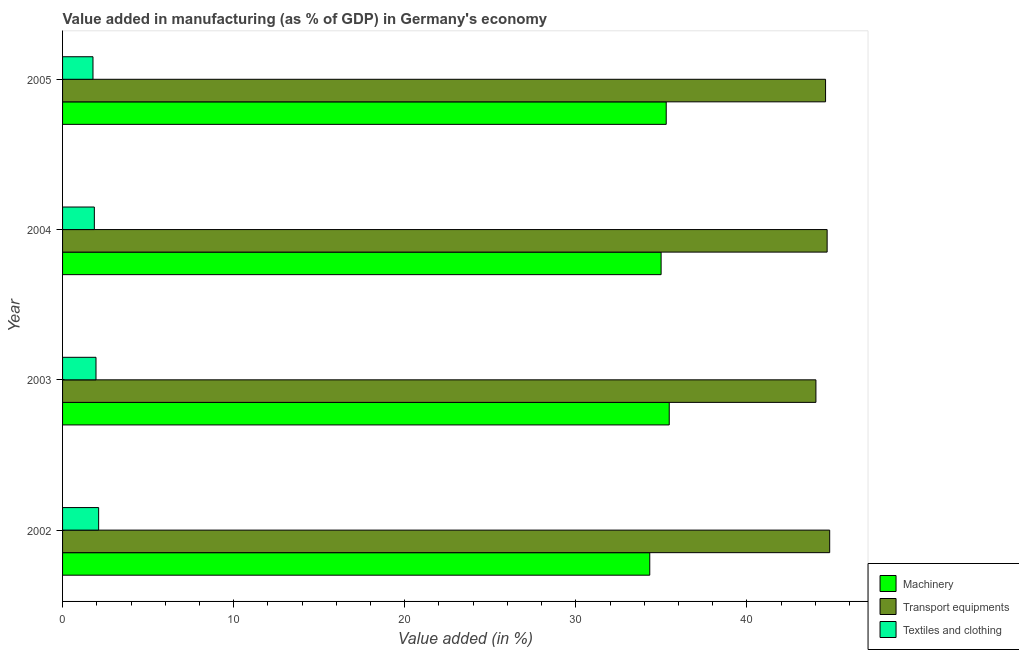How many different coloured bars are there?
Keep it short and to the point. 3. Are the number of bars per tick equal to the number of legend labels?
Your answer should be very brief. Yes. Are the number of bars on each tick of the Y-axis equal?
Offer a terse response. Yes. How many bars are there on the 3rd tick from the top?
Keep it short and to the point. 3. How many bars are there on the 3rd tick from the bottom?
Make the answer very short. 3. In how many cases, is the number of bars for a given year not equal to the number of legend labels?
Give a very brief answer. 0. What is the value added in manufacturing transport equipments in 2002?
Ensure brevity in your answer.  44.84. Across all years, what is the maximum value added in manufacturing textile and clothing?
Keep it short and to the point. 2.11. Across all years, what is the minimum value added in manufacturing textile and clothing?
Your answer should be very brief. 1.78. In which year was the value added in manufacturing textile and clothing maximum?
Provide a succinct answer. 2002. In which year was the value added in manufacturing textile and clothing minimum?
Your response must be concise. 2005. What is the total value added in manufacturing machinery in the graph?
Make the answer very short. 140.04. What is the difference between the value added in manufacturing machinery in 2002 and that in 2004?
Your response must be concise. -0.66. What is the difference between the value added in manufacturing machinery in 2003 and the value added in manufacturing transport equipments in 2004?
Provide a succinct answer. -9.23. What is the average value added in manufacturing transport equipments per year?
Make the answer very short. 44.54. In the year 2003, what is the difference between the value added in manufacturing machinery and value added in manufacturing textile and clothing?
Your response must be concise. 33.5. What is the ratio of the value added in manufacturing textile and clothing in 2002 to that in 2005?
Ensure brevity in your answer.  1.19. Is the value added in manufacturing machinery in 2003 less than that in 2004?
Provide a short and direct response. No. Is the difference between the value added in manufacturing textile and clothing in 2004 and 2005 greater than the difference between the value added in manufacturing machinery in 2004 and 2005?
Your answer should be compact. Yes. What is the difference between the highest and the second highest value added in manufacturing transport equipments?
Your response must be concise. 0.15. What is the difference between the highest and the lowest value added in manufacturing textile and clothing?
Ensure brevity in your answer.  0.33. What does the 1st bar from the top in 2004 represents?
Keep it short and to the point. Textiles and clothing. What does the 1st bar from the bottom in 2003 represents?
Provide a short and direct response. Machinery. How many bars are there?
Ensure brevity in your answer.  12. How many years are there in the graph?
Your answer should be compact. 4. What is the difference between two consecutive major ticks on the X-axis?
Offer a terse response. 10. Are the values on the major ticks of X-axis written in scientific E-notation?
Provide a short and direct response. No. Does the graph contain any zero values?
Your answer should be compact. No. Does the graph contain grids?
Your response must be concise. No. How are the legend labels stacked?
Make the answer very short. Vertical. What is the title of the graph?
Make the answer very short. Value added in manufacturing (as % of GDP) in Germany's economy. What is the label or title of the X-axis?
Provide a short and direct response. Value added (in %). What is the Value added (in %) in Machinery in 2002?
Provide a short and direct response. 34.32. What is the Value added (in %) of Transport equipments in 2002?
Your response must be concise. 44.84. What is the Value added (in %) in Textiles and clothing in 2002?
Your response must be concise. 2.11. What is the Value added (in %) of Machinery in 2003?
Offer a terse response. 35.46. What is the Value added (in %) of Transport equipments in 2003?
Keep it short and to the point. 44.03. What is the Value added (in %) of Textiles and clothing in 2003?
Offer a very short reply. 1.95. What is the Value added (in %) in Machinery in 2004?
Ensure brevity in your answer.  34.98. What is the Value added (in %) of Transport equipments in 2004?
Your answer should be compact. 44.69. What is the Value added (in %) of Textiles and clothing in 2004?
Offer a very short reply. 1.86. What is the Value added (in %) in Machinery in 2005?
Offer a very short reply. 35.28. What is the Value added (in %) in Transport equipments in 2005?
Provide a succinct answer. 44.6. What is the Value added (in %) of Textiles and clothing in 2005?
Provide a short and direct response. 1.78. Across all years, what is the maximum Value added (in %) of Machinery?
Ensure brevity in your answer.  35.46. Across all years, what is the maximum Value added (in %) of Transport equipments?
Your answer should be very brief. 44.84. Across all years, what is the maximum Value added (in %) in Textiles and clothing?
Give a very brief answer. 2.11. Across all years, what is the minimum Value added (in %) in Machinery?
Keep it short and to the point. 34.32. Across all years, what is the minimum Value added (in %) in Transport equipments?
Offer a terse response. 44.03. Across all years, what is the minimum Value added (in %) in Textiles and clothing?
Offer a terse response. 1.78. What is the total Value added (in %) of Machinery in the graph?
Give a very brief answer. 140.04. What is the total Value added (in %) in Transport equipments in the graph?
Offer a very short reply. 178.15. What is the total Value added (in %) in Textiles and clothing in the graph?
Keep it short and to the point. 7.7. What is the difference between the Value added (in %) of Machinery in 2002 and that in 2003?
Your answer should be very brief. -1.14. What is the difference between the Value added (in %) of Transport equipments in 2002 and that in 2003?
Provide a succinct answer. 0.8. What is the difference between the Value added (in %) in Textiles and clothing in 2002 and that in 2003?
Your answer should be very brief. 0.15. What is the difference between the Value added (in %) in Machinery in 2002 and that in 2004?
Your answer should be compact. -0.66. What is the difference between the Value added (in %) of Transport equipments in 2002 and that in 2004?
Offer a very short reply. 0.15. What is the difference between the Value added (in %) of Textiles and clothing in 2002 and that in 2004?
Your answer should be compact. 0.25. What is the difference between the Value added (in %) in Machinery in 2002 and that in 2005?
Offer a terse response. -0.96. What is the difference between the Value added (in %) in Transport equipments in 2002 and that in 2005?
Your answer should be compact. 0.24. What is the difference between the Value added (in %) of Textiles and clothing in 2002 and that in 2005?
Your answer should be very brief. 0.33. What is the difference between the Value added (in %) in Machinery in 2003 and that in 2004?
Ensure brevity in your answer.  0.48. What is the difference between the Value added (in %) of Transport equipments in 2003 and that in 2004?
Your answer should be very brief. -0.65. What is the difference between the Value added (in %) of Textiles and clothing in 2003 and that in 2004?
Give a very brief answer. 0.1. What is the difference between the Value added (in %) in Machinery in 2003 and that in 2005?
Give a very brief answer. 0.18. What is the difference between the Value added (in %) in Transport equipments in 2003 and that in 2005?
Provide a short and direct response. -0.56. What is the difference between the Value added (in %) of Textiles and clothing in 2003 and that in 2005?
Ensure brevity in your answer.  0.18. What is the difference between the Value added (in %) of Machinery in 2004 and that in 2005?
Keep it short and to the point. -0.3. What is the difference between the Value added (in %) in Transport equipments in 2004 and that in 2005?
Keep it short and to the point. 0.09. What is the difference between the Value added (in %) in Textiles and clothing in 2004 and that in 2005?
Provide a succinct answer. 0.08. What is the difference between the Value added (in %) in Machinery in 2002 and the Value added (in %) in Transport equipments in 2003?
Your answer should be very brief. -9.71. What is the difference between the Value added (in %) of Machinery in 2002 and the Value added (in %) of Textiles and clothing in 2003?
Your response must be concise. 32.37. What is the difference between the Value added (in %) in Transport equipments in 2002 and the Value added (in %) in Textiles and clothing in 2003?
Provide a short and direct response. 42.88. What is the difference between the Value added (in %) of Machinery in 2002 and the Value added (in %) of Transport equipments in 2004?
Provide a succinct answer. -10.37. What is the difference between the Value added (in %) in Machinery in 2002 and the Value added (in %) in Textiles and clothing in 2004?
Your answer should be very brief. 32.46. What is the difference between the Value added (in %) in Transport equipments in 2002 and the Value added (in %) in Textiles and clothing in 2004?
Make the answer very short. 42.98. What is the difference between the Value added (in %) of Machinery in 2002 and the Value added (in %) of Transport equipments in 2005?
Ensure brevity in your answer.  -10.27. What is the difference between the Value added (in %) in Machinery in 2002 and the Value added (in %) in Textiles and clothing in 2005?
Provide a short and direct response. 32.54. What is the difference between the Value added (in %) in Transport equipments in 2002 and the Value added (in %) in Textiles and clothing in 2005?
Give a very brief answer. 43.06. What is the difference between the Value added (in %) in Machinery in 2003 and the Value added (in %) in Transport equipments in 2004?
Offer a terse response. -9.23. What is the difference between the Value added (in %) in Machinery in 2003 and the Value added (in %) in Textiles and clothing in 2004?
Keep it short and to the point. 33.6. What is the difference between the Value added (in %) in Transport equipments in 2003 and the Value added (in %) in Textiles and clothing in 2004?
Give a very brief answer. 42.17. What is the difference between the Value added (in %) in Machinery in 2003 and the Value added (in %) in Transport equipments in 2005?
Make the answer very short. -9.14. What is the difference between the Value added (in %) of Machinery in 2003 and the Value added (in %) of Textiles and clothing in 2005?
Your response must be concise. 33.68. What is the difference between the Value added (in %) of Transport equipments in 2003 and the Value added (in %) of Textiles and clothing in 2005?
Provide a short and direct response. 42.25. What is the difference between the Value added (in %) in Machinery in 2004 and the Value added (in %) in Transport equipments in 2005?
Give a very brief answer. -9.61. What is the difference between the Value added (in %) of Machinery in 2004 and the Value added (in %) of Textiles and clothing in 2005?
Your response must be concise. 33.21. What is the difference between the Value added (in %) of Transport equipments in 2004 and the Value added (in %) of Textiles and clothing in 2005?
Make the answer very short. 42.91. What is the average Value added (in %) of Machinery per year?
Keep it short and to the point. 35.01. What is the average Value added (in %) in Transport equipments per year?
Your answer should be very brief. 44.54. What is the average Value added (in %) of Textiles and clothing per year?
Provide a short and direct response. 1.92. In the year 2002, what is the difference between the Value added (in %) in Machinery and Value added (in %) in Transport equipments?
Your answer should be very brief. -10.52. In the year 2002, what is the difference between the Value added (in %) of Machinery and Value added (in %) of Textiles and clothing?
Your response must be concise. 32.21. In the year 2002, what is the difference between the Value added (in %) in Transport equipments and Value added (in %) in Textiles and clothing?
Offer a very short reply. 42.73. In the year 2003, what is the difference between the Value added (in %) of Machinery and Value added (in %) of Transport equipments?
Keep it short and to the point. -8.57. In the year 2003, what is the difference between the Value added (in %) of Machinery and Value added (in %) of Textiles and clothing?
Make the answer very short. 33.5. In the year 2003, what is the difference between the Value added (in %) in Transport equipments and Value added (in %) in Textiles and clothing?
Keep it short and to the point. 42.08. In the year 2004, what is the difference between the Value added (in %) of Machinery and Value added (in %) of Transport equipments?
Ensure brevity in your answer.  -9.7. In the year 2004, what is the difference between the Value added (in %) of Machinery and Value added (in %) of Textiles and clothing?
Your answer should be compact. 33.13. In the year 2004, what is the difference between the Value added (in %) of Transport equipments and Value added (in %) of Textiles and clothing?
Keep it short and to the point. 42.83. In the year 2005, what is the difference between the Value added (in %) of Machinery and Value added (in %) of Transport equipments?
Your answer should be compact. -9.31. In the year 2005, what is the difference between the Value added (in %) of Machinery and Value added (in %) of Textiles and clothing?
Give a very brief answer. 33.5. In the year 2005, what is the difference between the Value added (in %) of Transport equipments and Value added (in %) of Textiles and clothing?
Make the answer very short. 42.82. What is the ratio of the Value added (in %) of Machinery in 2002 to that in 2003?
Offer a very short reply. 0.97. What is the ratio of the Value added (in %) in Transport equipments in 2002 to that in 2003?
Give a very brief answer. 1.02. What is the ratio of the Value added (in %) of Textiles and clothing in 2002 to that in 2003?
Your answer should be compact. 1.08. What is the ratio of the Value added (in %) of Machinery in 2002 to that in 2004?
Your response must be concise. 0.98. What is the ratio of the Value added (in %) of Transport equipments in 2002 to that in 2004?
Give a very brief answer. 1. What is the ratio of the Value added (in %) in Textiles and clothing in 2002 to that in 2004?
Provide a short and direct response. 1.14. What is the ratio of the Value added (in %) in Machinery in 2002 to that in 2005?
Provide a succinct answer. 0.97. What is the ratio of the Value added (in %) in Transport equipments in 2002 to that in 2005?
Give a very brief answer. 1.01. What is the ratio of the Value added (in %) in Textiles and clothing in 2002 to that in 2005?
Your answer should be very brief. 1.19. What is the ratio of the Value added (in %) in Machinery in 2003 to that in 2004?
Your response must be concise. 1.01. What is the ratio of the Value added (in %) of Transport equipments in 2003 to that in 2004?
Keep it short and to the point. 0.99. What is the ratio of the Value added (in %) in Textiles and clothing in 2003 to that in 2004?
Keep it short and to the point. 1.05. What is the ratio of the Value added (in %) in Machinery in 2003 to that in 2005?
Your answer should be very brief. 1. What is the ratio of the Value added (in %) in Transport equipments in 2003 to that in 2005?
Your answer should be compact. 0.99. What is the ratio of the Value added (in %) of Textiles and clothing in 2003 to that in 2005?
Offer a terse response. 1.1. What is the ratio of the Value added (in %) of Transport equipments in 2004 to that in 2005?
Make the answer very short. 1. What is the ratio of the Value added (in %) in Textiles and clothing in 2004 to that in 2005?
Provide a short and direct response. 1.04. What is the difference between the highest and the second highest Value added (in %) of Machinery?
Offer a terse response. 0.18. What is the difference between the highest and the second highest Value added (in %) of Transport equipments?
Keep it short and to the point. 0.15. What is the difference between the highest and the second highest Value added (in %) in Textiles and clothing?
Keep it short and to the point. 0.15. What is the difference between the highest and the lowest Value added (in %) of Machinery?
Offer a terse response. 1.14. What is the difference between the highest and the lowest Value added (in %) in Transport equipments?
Offer a terse response. 0.8. What is the difference between the highest and the lowest Value added (in %) of Textiles and clothing?
Your answer should be compact. 0.33. 